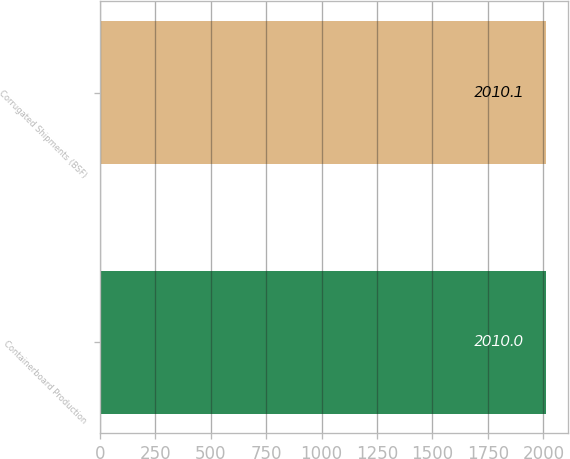<chart> <loc_0><loc_0><loc_500><loc_500><bar_chart><fcel>Containerboard Production<fcel>Corrugated Shipments (BSF)<nl><fcel>2010<fcel>2010.1<nl></chart> 